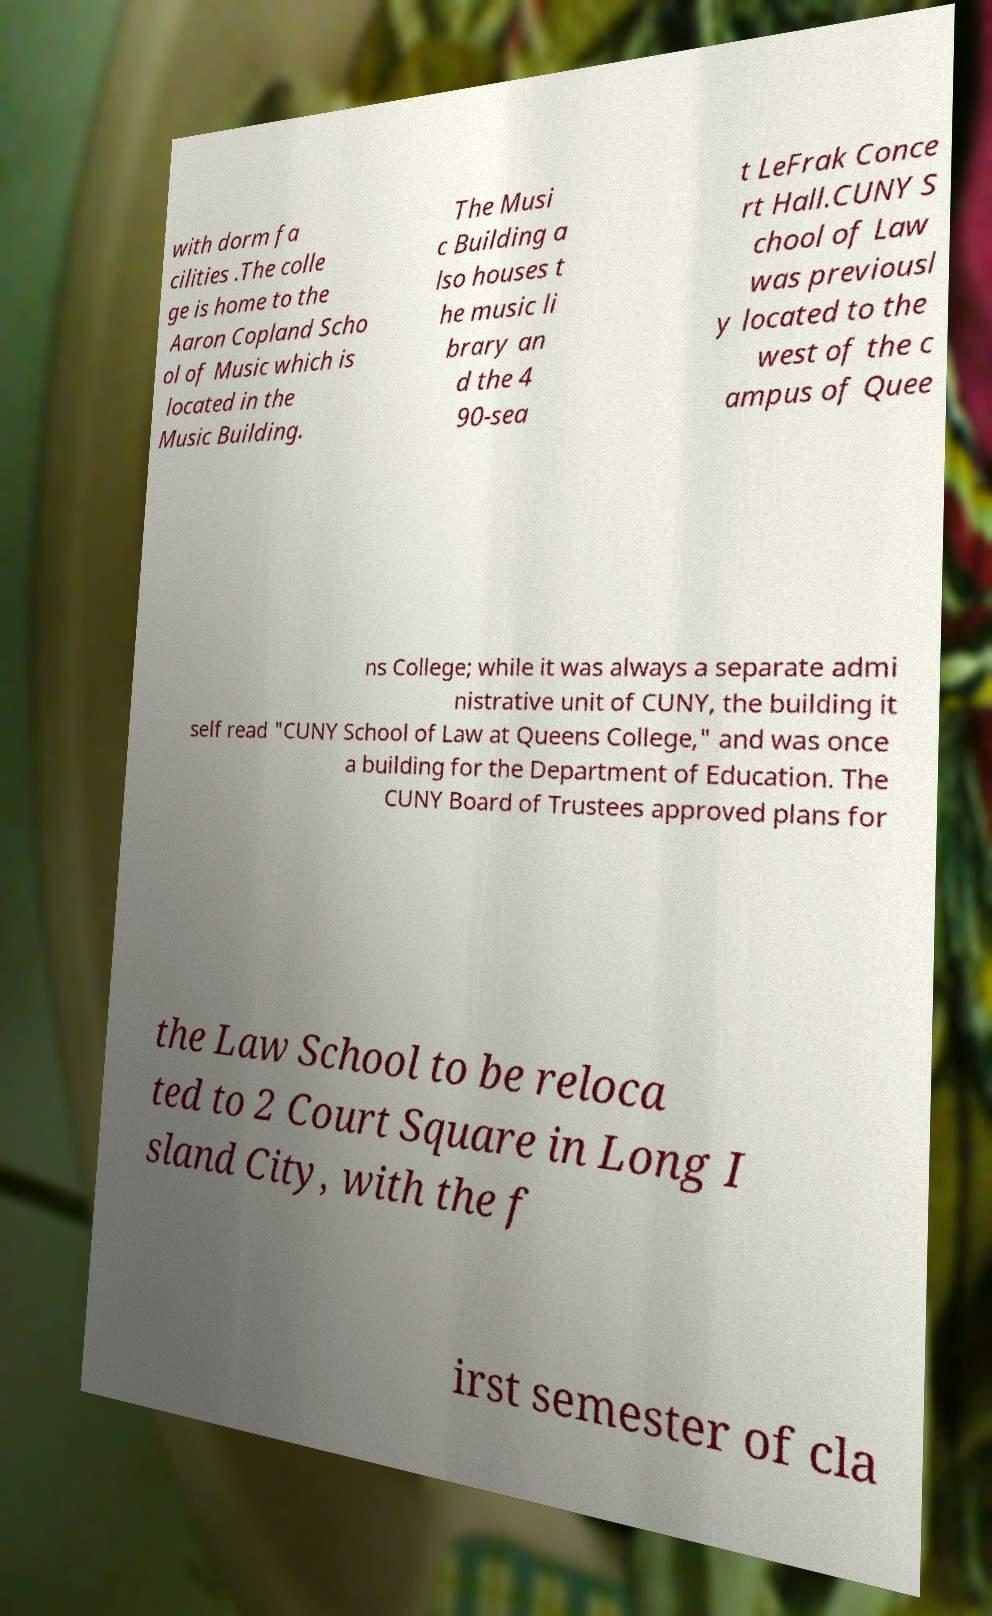Can you accurately transcribe the text from the provided image for me? with dorm fa cilities .The colle ge is home to the Aaron Copland Scho ol of Music which is located in the Music Building. The Musi c Building a lso houses t he music li brary an d the 4 90-sea t LeFrak Conce rt Hall.CUNY S chool of Law was previousl y located to the west of the c ampus of Quee ns College; while it was always a separate admi nistrative unit of CUNY, the building it self read "CUNY School of Law at Queens College," and was once a building for the Department of Education. The CUNY Board of Trustees approved plans for the Law School to be reloca ted to 2 Court Square in Long I sland City, with the f irst semester of cla 